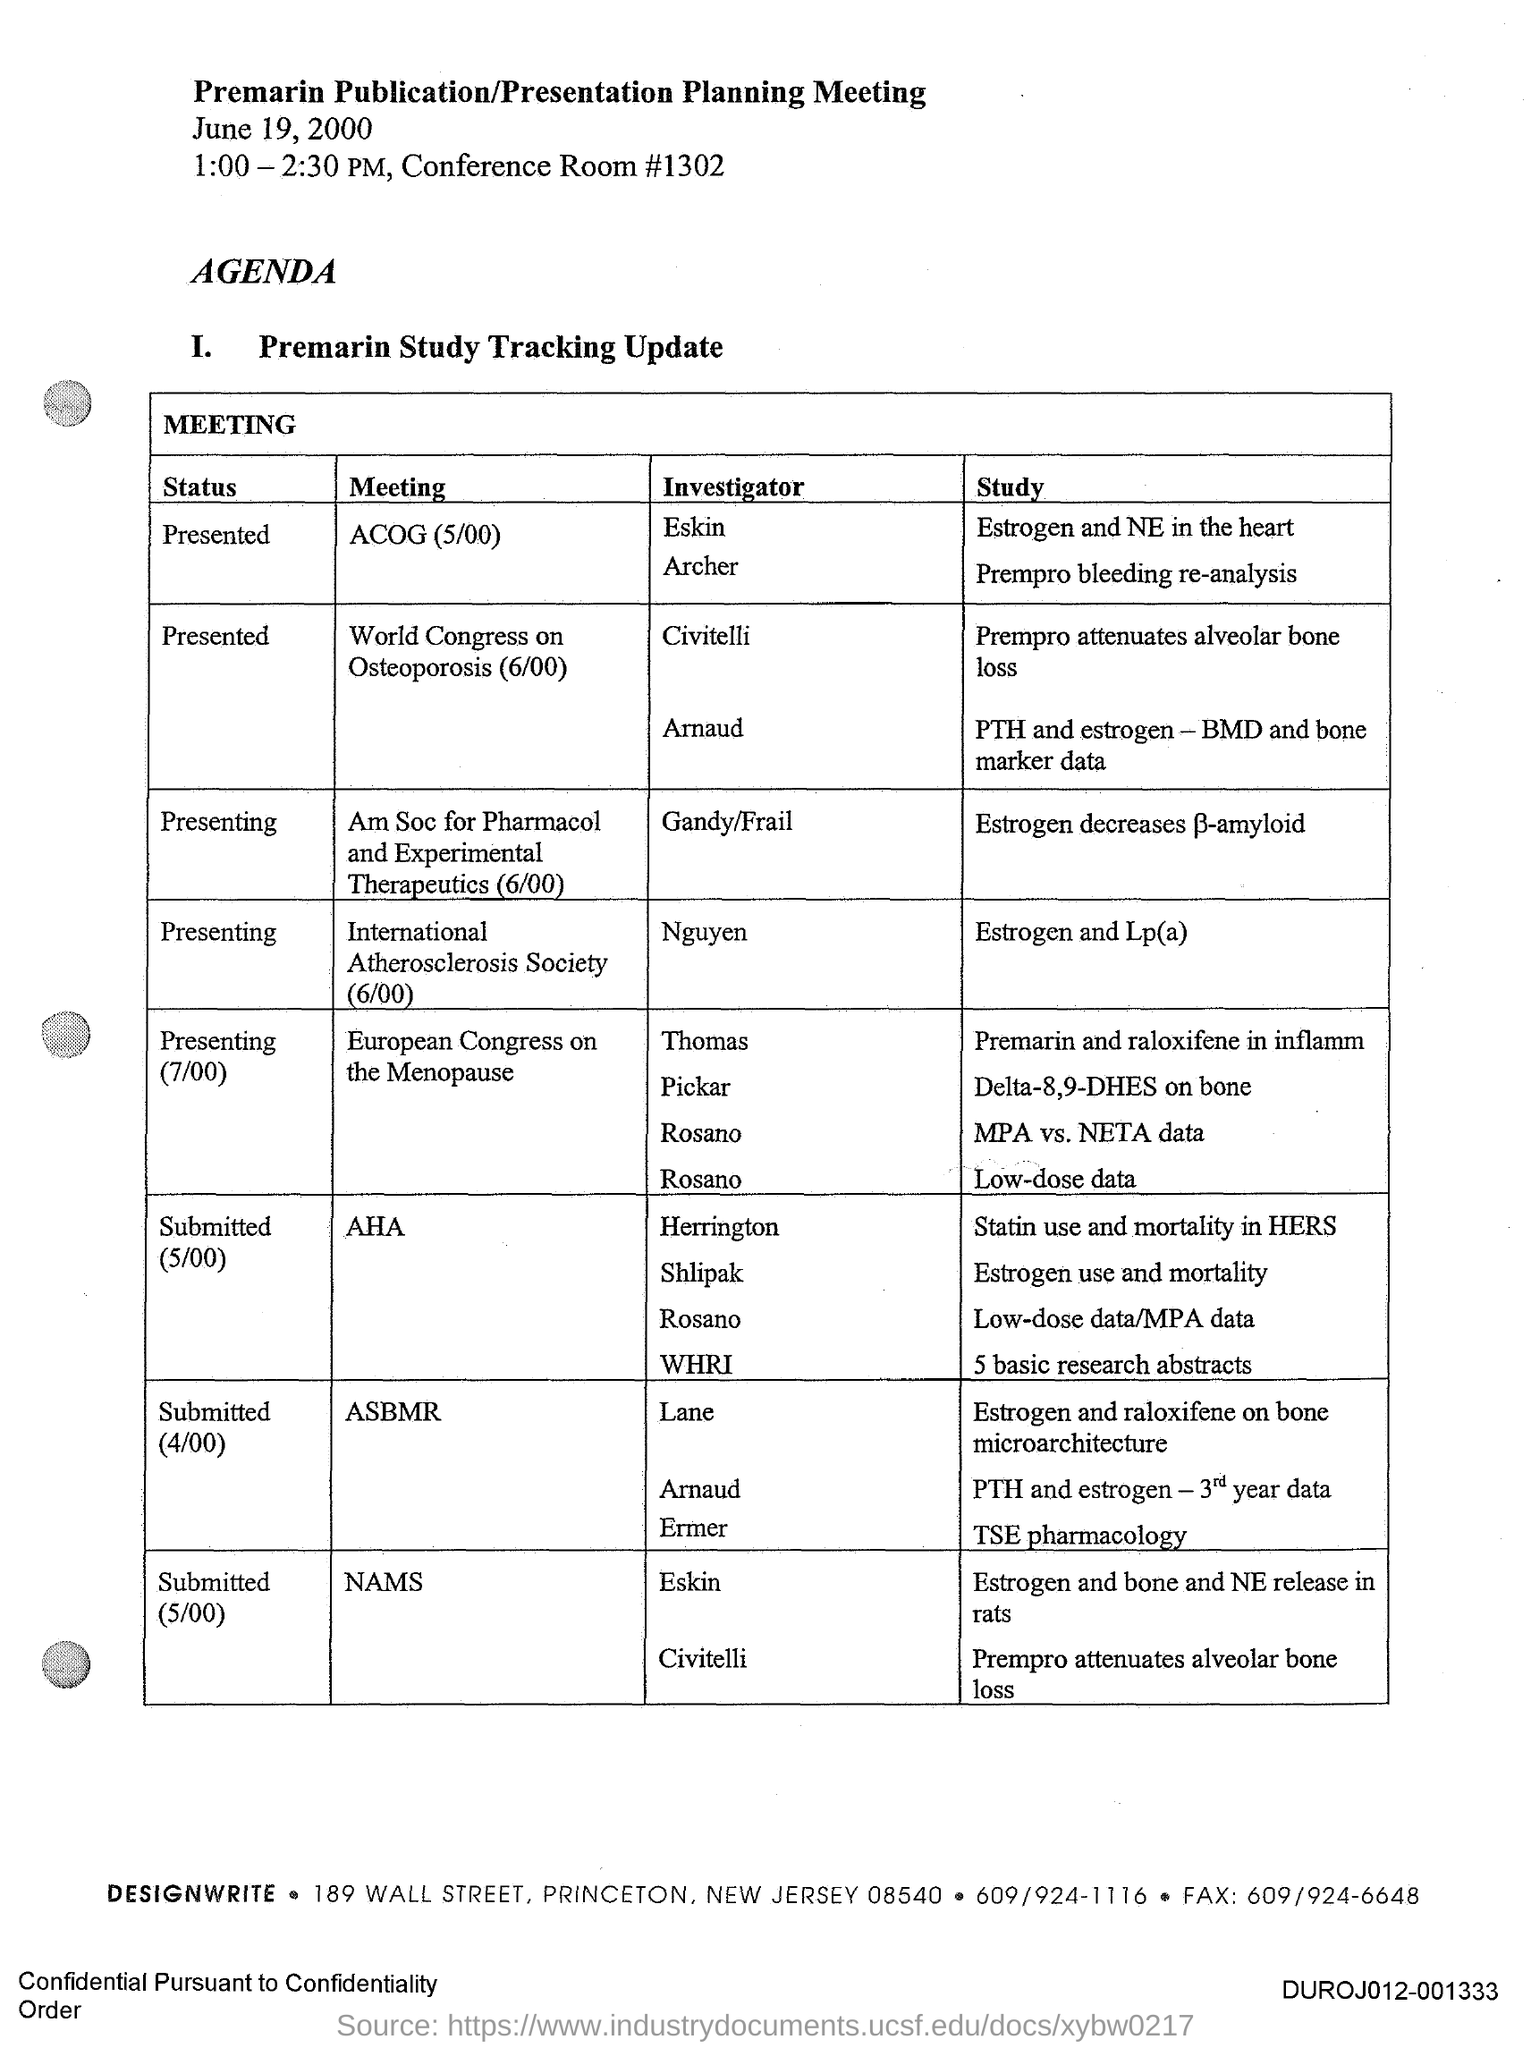Outline some significant characteristics in this image. On June 19, 2000, the Premarin Publication/Presentation Planning Meeting was held. The investigator for the study "Estrogen and Lp(a)" is Nguyen. The study "Estrogen and Lp(a)" is currently ongoing and its status is unknown. The Premarin Publication/Presentation Planning Meeting is scheduled to take place from 1:00 PM to 2:30 PM. 